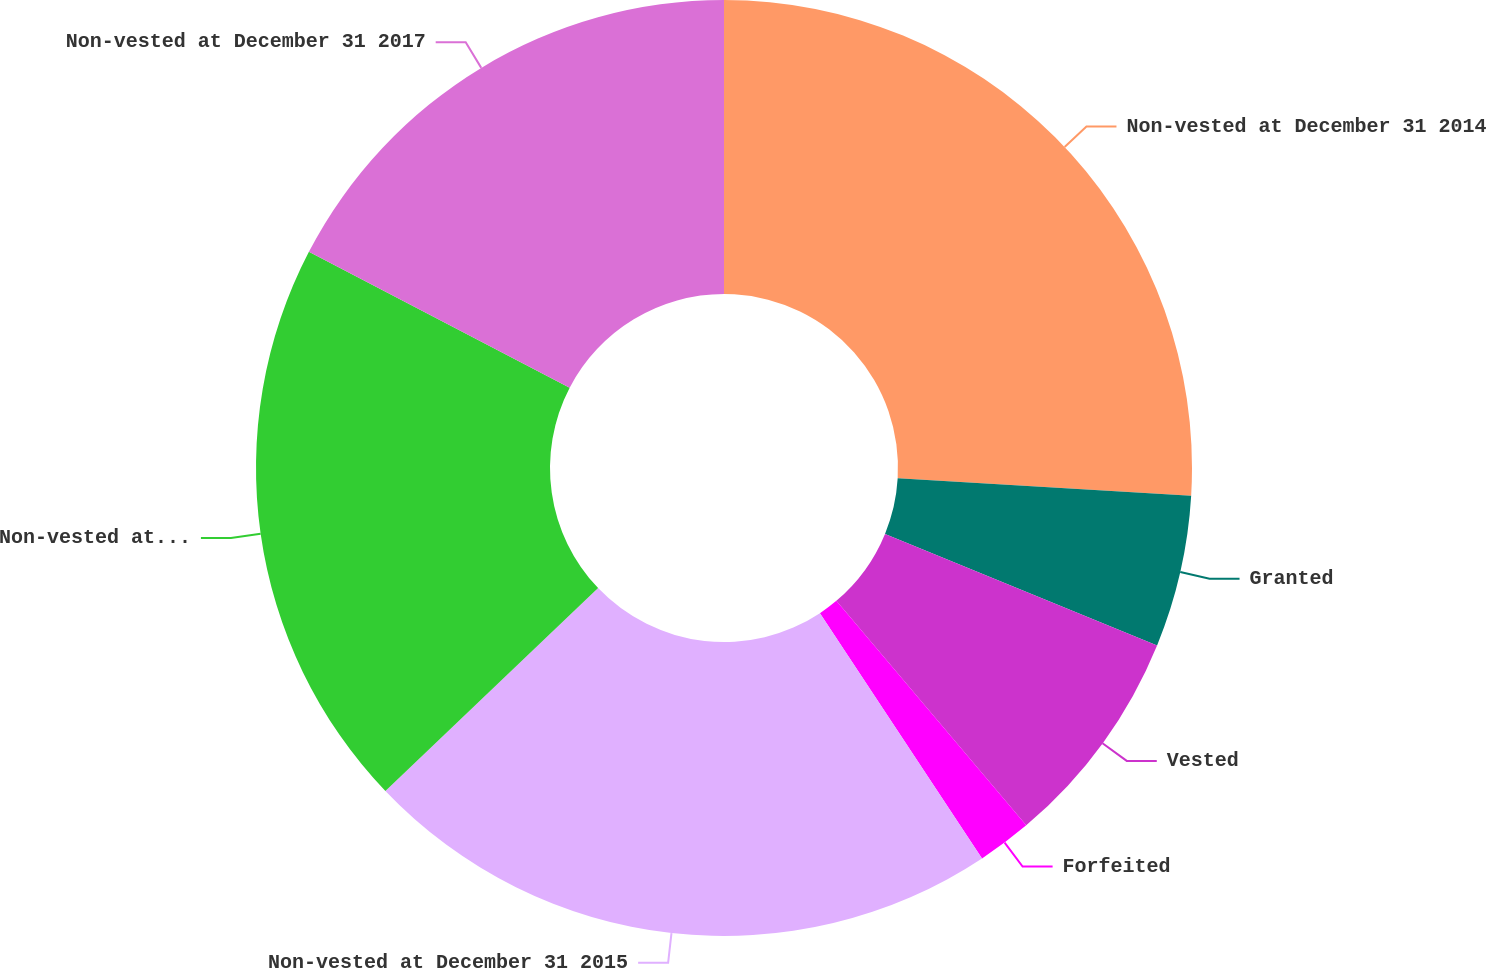Convert chart. <chart><loc_0><loc_0><loc_500><loc_500><pie_chart><fcel>Non-vested at December 31 2014<fcel>Granted<fcel>Vested<fcel>Forfeited<fcel>Non-vested at December 31 2015<fcel>Non-vested at December 31 2016<fcel>Non-vested at December 31 2017<nl><fcel>25.95%<fcel>5.24%<fcel>7.64%<fcel>1.88%<fcel>22.17%<fcel>19.77%<fcel>17.36%<nl></chart> 